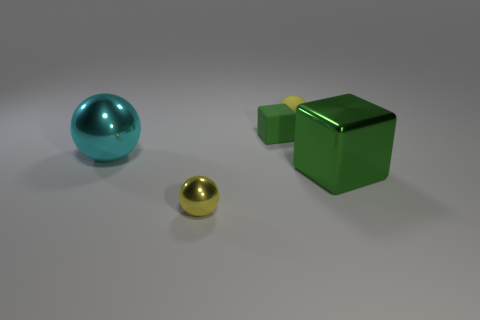Add 2 big cyan balls. How many objects exist? 7 Subtract all balls. How many objects are left? 2 Subtract all large shiny balls. Subtract all matte cubes. How many objects are left? 3 Add 3 green cubes. How many green cubes are left? 5 Add 2 cyan metal things. How many cyan metal things exist? 3 Subtract 0 purple balls. How many objects are left? 5 